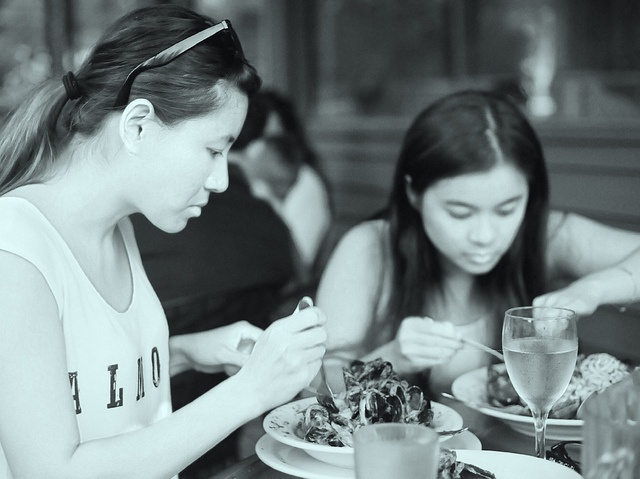Describe the objects in this image and their specific colors. I can see people in purple, lightblue, black, and gray tones, people in purple, black, darkgray, and lightblue tones, people in purple, black, gray, and darkgray tones, people in purple, black, gray, darkgray, and lightblue tones, and wine glass in purple, darkgray, lightblue, and gray tones in this image. 